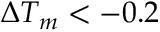<formula> <loc_0><loc_0><loc_500><loc_500>\Delta T _ { m } < - 0 . 2</formula> 